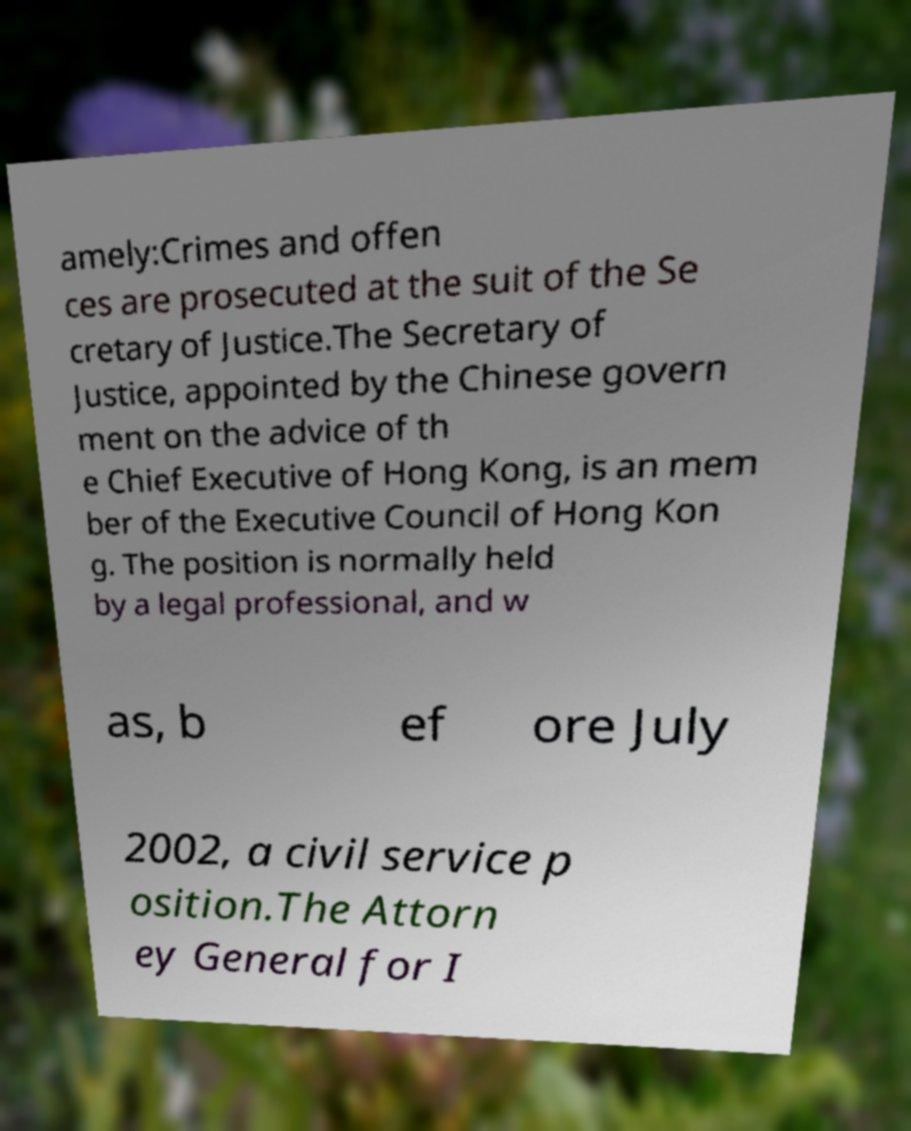Could you assist in decoding the text presented in this image and type it out clearly? amely:Crimes and offen ces are prosecuted at the suit of the Se cretary of Justice.The Secretary of Justice, appointed by the Chinese govern ment on the advice of th e Chief Executive of Hong Kong, is an mem ber of the Executive Council of Hong Kon g. The position is normally held by a legal professional, and w as, b ef ore July 2002, a civil service p osition.The Attorn ey General for I 